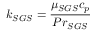<formula> <loc_0><loc_0><loc_500><loc_500>k _ { S G S } = \frac { \mu _ { S G S } c _ { p } } { P r _ { S G S } }</formula> 